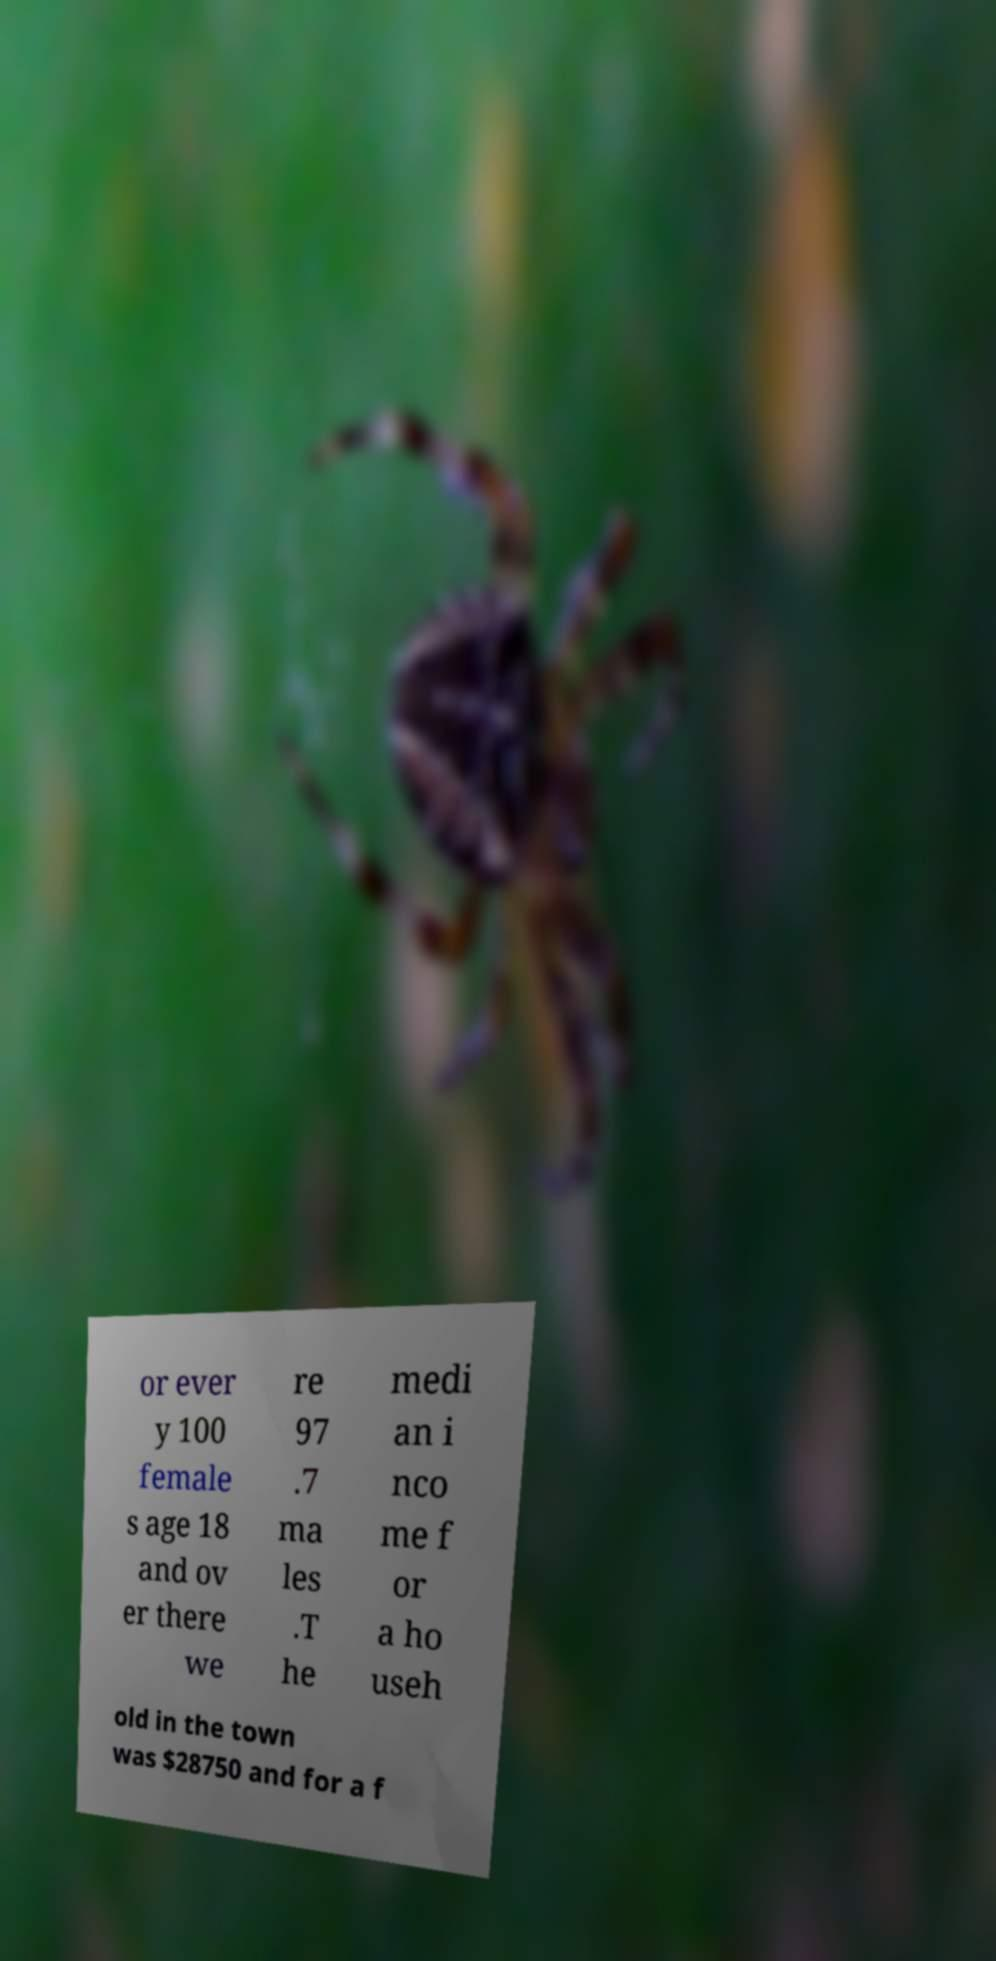I need the written content from this picture converted into text. Can you do that? or ever y 100 female s age 18 and ov er there we re 97 .7 ma les .T he medi an i nco me f or a ho useh old in the town was $28750 and for a f 